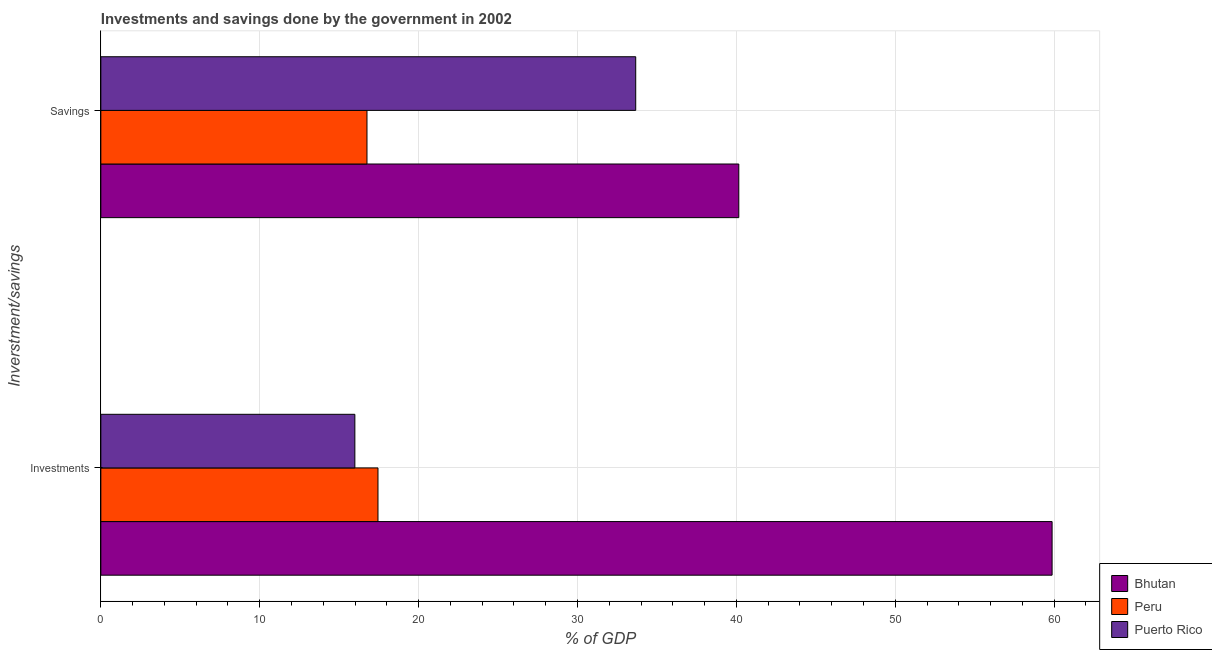How many different coloured bars are there?
Provide a short and direct response. 3. How many groups of bars are there?
Offer a terse response. 2. How many bars are there on the 1st tick from the top?
Your answer should be compact. 3. What is the label of the 2nd group of bars from the top?
Offer a very short reply. Investments. What is the investments of government in Peru?
Your response must be concise. 17.44. Across all countries, what is the maximum investments of government?
Offer a terse response. 59.87. Across all countries, what is the minimum savings of government?
Give a very brief answer. 16.75. In which country was the savings of government maximum?
Give a very brief answer. Bhutan. In which country was the investments of government minimum?
Make the answer very short. Puerto Rico. What is the total savings of government in the graph?
Ensure brevity in your answer.  90.57. What is the difference between the investments of government in Peru and that in Puerto Rico?
Offer a very short reply. 1.46. What is the difference between the investments of government in Peru and the savings of government in Puerto Rico?
Provide a succinct answer. -16.22. What is the average investments of government per country?
Your answer should be compact. 31.1. What is the difference between the investments of government and savings of government in Puerto Rico?
Make the answer very short. -17.68. In how many countries, is the investments of government greater than 22 %?
Offer a very short reply. 1. What is the ratio of the savings of government in Bhutan to that in Peru?
Offer a very short reply. 2.4. What does the 1st bar from the top in Investments represents?
Provide a succinct answer. Puerto Rico. What does the 3rd bar from the bottom in Investments represents?
Your answer should be compact. Puerto Rico. How many bars are there?
Keep it short and to the point. 6. Are the values on the major ticks of X-axis written in scientific E-notation?
Give a very brief answer. No. Does the graph contain grids?
Give a very brief answer. Yes. Where does the legend appear in the graph?
Keep it short and to the point. Bottom right. How many legend labels are there?
Provide a short and direct response. 3. What is the title of the graph?
Your answer should be compact. Investments and savings done by the government in 2002. What is the label or title of the X-axis?
Your answer should be compact. % of GDP. What is the label or title of the Y-axis?
Make the answer very short. Inverstment/savings. What is the % of GDP of Bhutan in Investments?
Ensure brevity in your answer.  59.87. What is the % of GDP in Peru in Investments?
Your answer should be very brief. 17.44. What is the % of GDP of Puerto Rico in Investments?
Provide a short and direct response. 15.99. What is the % of GDP in Bhutan in Savings?
Provide a succinct answer. 40.15. What is the % of GDP of Peru in Savings?
Give a very brief answer. 16.75. What is the % of GDP in Puerto Rico in Savings?
Your response must be concise. 33.66. Across all Inverstment/savings, what is the maximum % of GDP of Bhutan?
Keep it short and to the point. 59.87. Across all Inverstment/savings, what is the maximum % of GDP in Peru?
Offer a very short reply. 17.44. Across all Inverstment/savings, what is the maximum % of GDP of Puerto Rico?
Your response must be concise. 33.66. Across all Inverstment/savings, what is the minimum % of GDP of Bhutan?
Offer a very short reply. 40.15. Across all Inverstment/savings, what is the minimum % of GDP of Peru?
Your answer should be very brief. 16.75. Across all Inverstment/savings, what is the minimum % of GDP of Puerto Rico?
Provide a short and direct response. 15.99. What is the total % of GDP of Bhutan in the graph?
Keep it short and to the point. 100.02. What is the total % of GDP in Peru in the graph?
Your answer should be very brief. 34.19. What is the total % of GDP in Puerto Rico in the graph?
Give a very brief answer. 49.65. What is the difference between the % of GDP of Bhutan in Investments and that in Savings?
Ensure brevity in your answer.  19.72. What is the difference between the % of GDP of Peru in Investments and that in Savings?
Give a very brief answer. 0.69. What is the difference between the % of GDP in Puerto Rico in Investments and that in Savings?
Your response must be concise. -17.68. What is the difference between the % of GDP of Bhutan in Investments and the % of GDP of Peru in Savings?
Provide a succinct answer. 43.12. What is the difference between the % of GDP in Bhutan in Investments and the % of GDP in Puerto Rico in Savings?
Your answer should be compact. 26.21. What is the difference between the % of GDP of Peru in Investments and the % of GDP of Puerto Rico in Savings?
Provide a succinct answer. -16.22. What is the average % of GDP of Bhutan per Inverstment/savings?
Your response must be concise. 50.01. What is the average % of GDP in Peru per Inverstment/savings?
Your answer should be compact. 17.1. What is the average % of GDP of Puerto Rico per Inverstment/savings?
Your answer should be very brief. 24.83. What is the difference between the % of GDP in Bhutan and % of GDP in Peru in Investments?
Provide a short and direct response. 42.43. What is the difference between the % of GDP of Bhutan and % of GDP of Puerto Rico in Investments?
Provide a succinct answer. 43.88. What is the difference between the % of GDP in Peru and % of GDP in Puerto Rico in Investments?
Your response must be concise. 1.46. What is the difference between the % of GDP of Bhutan and % of GDP of Peru in Savings?
Your response must be concise. 23.4. What is the difference between the % of GDP in Bhutan and % of GDP in Puerto Rico in Savings?
Keep it short and to the point. 6.49. What is the difference between the % of GDP in Peru and % of GDP in Puerto Rico in Savings?
Your answer should be compact. -16.91. What is the ratio of the % of GDP in Bhutan in Investments to that in Savings?
Your answer should be very brief. 1.49. What is the ratio of the % of GDP in Peru in Investments to that in Savings?
Ensure brevity in your answer.  1.04. What is the ratio of the % of GDP of Puerto Rico in Investments to that in Savings?
Offer a very short reply. 0.47. What is the difference between the highest and the second highest % of GDP in Bhutan?
Your response must be concise. 19.72. What is the difference between the highest and the second highest % of GDP in Peru?
Your response must be concise. 0.69. What is the difference between the highest and the second highest % of GDP of Puerto Rico?
Offer a very short reply. 17.68. What is the difference between the highest and the lowest % of GDP in Bhutan?
Keep it short and to the point. 19.72. What is the difference between the highest and the lowest % of GDP in Peru?
Your answer should be very brief. 0.69. What is the difference between the highest and the lowest % of GDP of Puerto Rico?
Offer a very short reply. 17.68. 